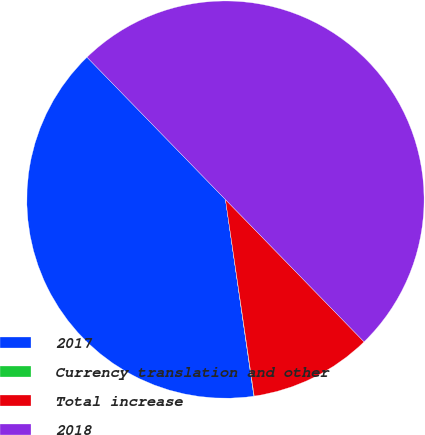Convert chart. <chart><loc_0><loc_0><loc_500><loc_500><pie_chart><fcel>2017<fcel>Currency translation and other<fcel>Total increase<fcel>2018<nl><fcel>40.01%<fcel>0.03%<fcel>9.98%<fcel>49.99%<nl></chart> 